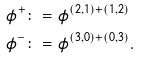Convert formula to latex. <formula><loc_0><loc_0><loc_500><loc_500>\phi ^ { + } \colon = & \ \phi ^ { ( 2 , 1 ) + ( 1 , 2 ) } \\ \phi ^ { - } \colon = & \ \phi ^ { ( 3 , 0 ) + ( 0 , 3 ) } .</formula> 